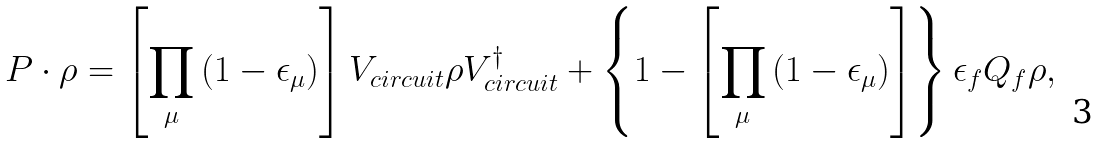<formula> <loc_0><loc_0><loc_500><loc_500>P \cdot \rho = \left [ \prod _ { \mu } \left ( 1 - \epsilon _ { \mu } \right ) \right ] V _ { c i r c u i t } \rho V _ { c i r c u i t } ^ { \dag } + \left \{ 1 - \left [ \prod _ { \mu } \left ( 1 - \epsilon _ { \mu } \right ) \right ] \right \} \epsilon _ { f } Q _ { f } \rho ,</formula> 